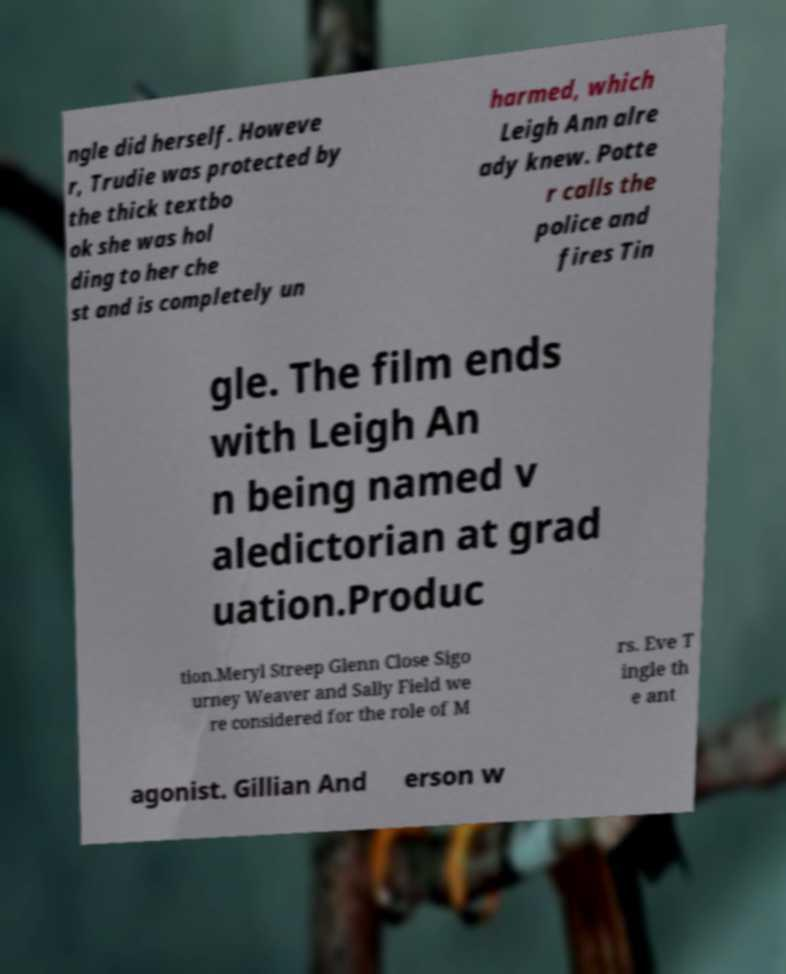I need the written content from this picture converted into text. Can you do that? ngle did herself. Howeve r, Trudie was protected by the thick textbo ok she was hol ding to her che st and is completely un harmed, which Leigh Ann alre ady knew. Potte r calls the police and fires Tin gle. The film ends with Leigh An n being named v aledictorian at grad uation.Produc tion.Meryl Streep Glenn Close Sigo urney Weaver and Sally Field we re considered for the role of M rs. Eve T ingle th e ant agonist. Gillian And erson w 